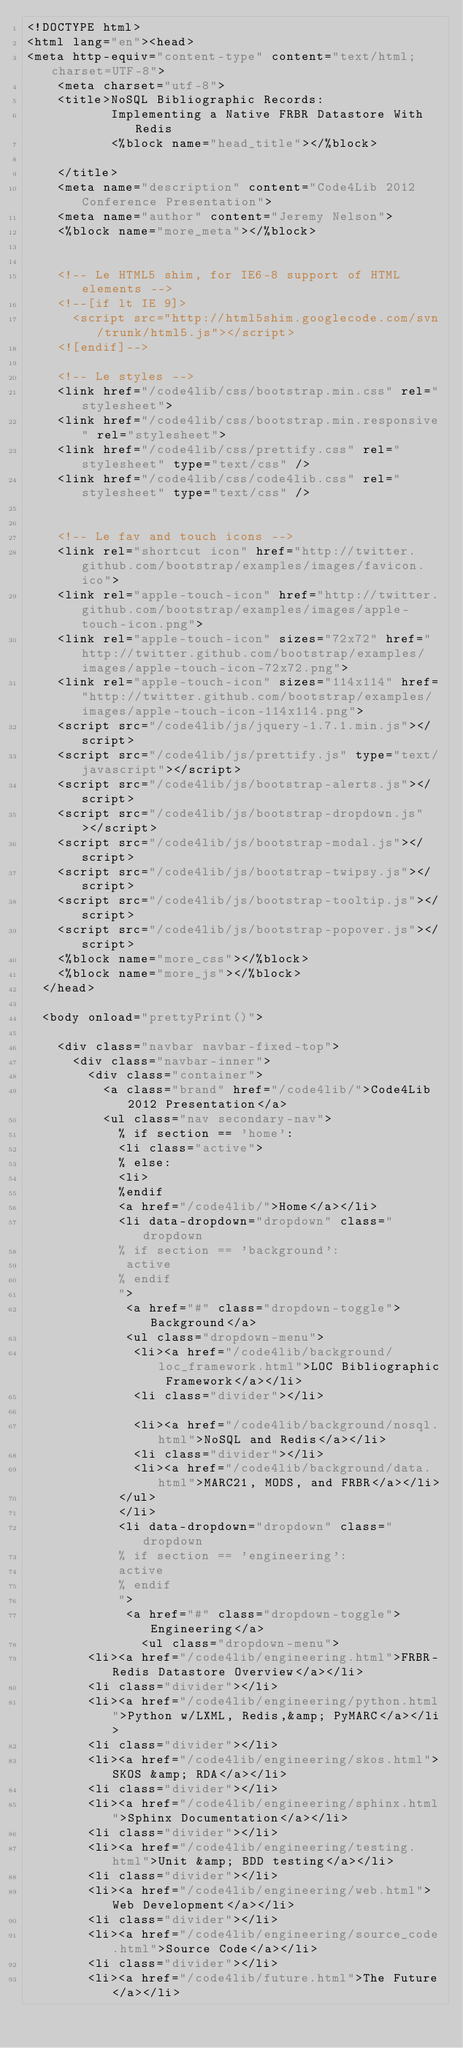<code> <loc_0><loc_0><loc_500><loc_500><_HTML_><!DOCTYPE html>
<html lang="en"><head>
<meta http-equiv="content-type" content="text/html; charset=UTF-8">
    <meta charset="utf-8">
    <title>NoSQL Bibliographic Records: 
           Implementing a Native FRBR Datastore With Redis
           <%block name="head_title"></%block>       
           
    </title>
    <meta name="description" content="Code4Lib 2012 Conference Presentation">
    <meta name="author" content="Jeremy Nelson">
    <%block name="more_meta"></%block>
    

    <!-- Le HTML5 shim, for IE6-8 support of HTML elements -->
    <!--[if lt IE 9]>
      <script src="http://html5shim.googlecode.com/svn/trunk/html5.js"></script>
    <![endif]-->

    <!-- Le styles -->
    <link href="/code4lib/css/bootstrap.min.css" rel="stylesheet">
    <link href="/code4lib/css/bootstrap.min.responsive" rel="stylesheet">
    <link href="/code4lib/css/prettify.css" rel="stylesheet" type="text/css" />
    <link href="/code4lib/css/code4lib.css" rel="stylesheet" type="text/css" />


    <!-- Le fav and touch icons -->
    <link rel="shortcut icon" href="http://twitter.github.com/bootstrap/examples/images/favicon.ico">
    <link rel="apple-touch-icon" href="http://twitter.github.com/bootstrap/examples/images/apple-touch-icon.png">
    <link rel="apple-touch-icon" sizes="72x72" href="http://twitter.github.com/bootstrap/examples/images/apple-touch-icon-72x72.png">
    <link rel="apple-touch-icon" sizes="114x114" href="http://twitter.github.com/bootstrap/examples/images/apple-touch-icon-114x114.png">
    <script src="/code4lib/js/jquery-1.7.1.min.js"></script>
    <script src="/code4lib/js/prettify.js" type="text/javascript"></script>
    <script src="/code4lib/js/bootstrap-alerts.js"></script>
    <script src="/code4lib/js/bootstrap-dropdown.js"></script>
    <script src="/code4lib/js/bootstrap-modal.js"></script>
    <script src="/code4lib/js/bootstrap-twipsy.js"></script>
    <script src="/code4lib/js/bootstrap-tooltip.js"></script>
    <script src="/code4lib/js/bootstrap-popover.js"></script>
    <%block name="more_css"></%block>
    <%block name="more_js"></%block>
  </head>

  <body onload="prettyPrint()">

    <div class="navbar navbar-fixed-top">
      <div class="navbar-inner">
        <div class="container">
          <a class="brand" href="/code4lib/">Code4Lib 2012 Presentation</a>
          <ul class="nav secondary-nav">
            % if section == 'home':
            <li class="active">
            % else:
            <li>
            %endif
            <a href="/code4lib/">Home</a></li>
            <li data-dropdown="dropdown" class="dropdown
            % if section == 'background':
             active
            % endif
            ">
             <a href="#" class="dropdown-toggle">Background</a>
             <ul class="dropdown-menu">
              <li><a href="/code4lib/background/loc_framework.html">LOC Bibliographic Framework</a></li>
              <li class="divider"></li>

              <li><a href="/code4lib/background/nosql.html">NoSQL and Redis</a></li>
              <li class="divider"></li>
              <li><a href="/code4lib/background/data.html">MARC21, MODS, and FRBR</a></li>
            </ul>
            </li>
            <li data-dropdown="dropdown" class="dropdown
            % if section == 'engineering':
            active
            % endif
            ">
             <a href="#" class="dropdown-toggle">Engineering</a>
               <ul class="dropdown-menu">
		<li><a href="/code4lib/engineering.html">FRBR-Redis Datastore Overview</a></li>
		<li class="divider"></li>
		<li><a href="/code4lib/engineering/python.html">Python w/LXML, Redis,&amp; PyMARC</a></li>
		<li class="divider"></li>
		<li><a href="/code4lib/engineering/skos.html">SKOS &amp; RDA</a></li>
		<li class="divider"></li>
		<li><a href="/code4lib/engineering/sphinx.html">Sphinx Documentation</a></li>
		<li class="divider"></li>
		<li><a href="/code4lib/engineering/testing.html">Unit &amp; BDD testing</a></li>
		<li class="divider"></li>
		<li><a href="/code4lib/engineering/web.html">Web Development</a></li>
		<li class="divider"></li>
		<li><a href="/code4lib/engineering/source_code.html">Source Code</a></li>
		<li class="divider"></li>
		<li><a href="/code4lib/future.html">The Future</a></li></code> 